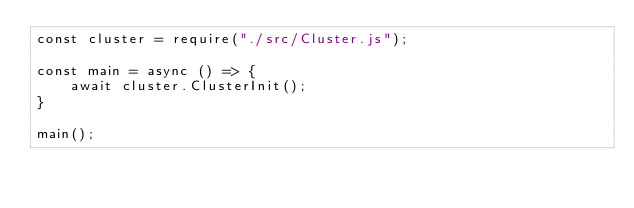Convert code to text. <code><loc_0><loc_0><loc_500><loc_500><_JavaScript_>const cluster = require("./src/Cluster.js");

const main = async () => {
    await cluster.ClusterInit();
}

main();</code> 